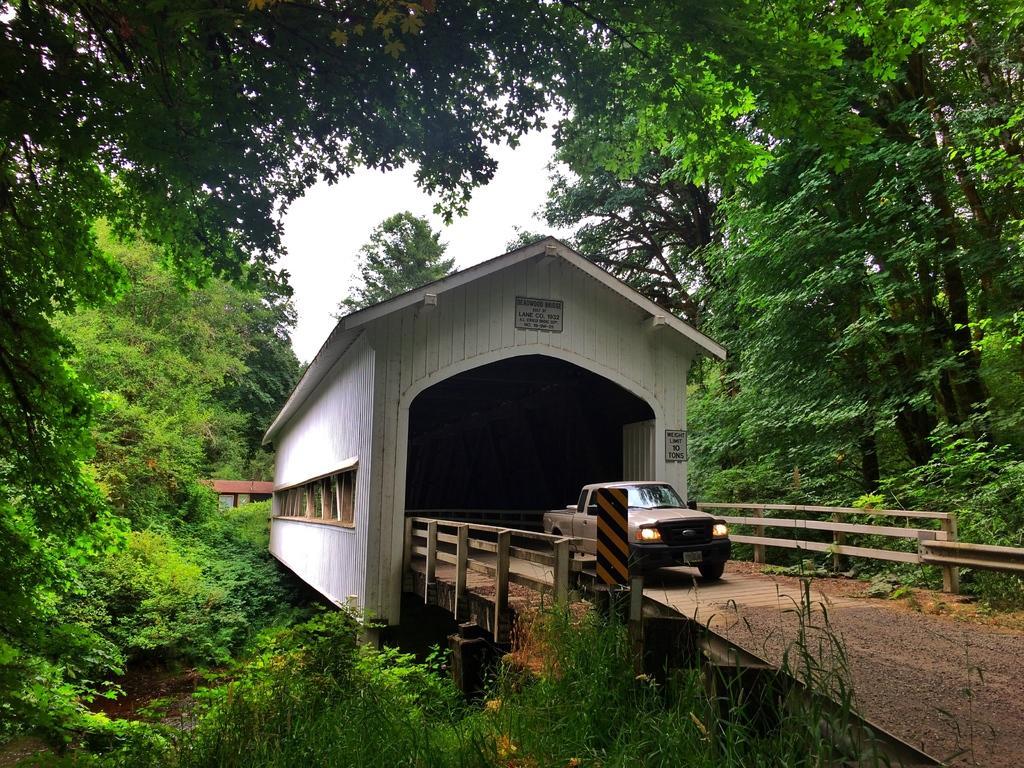Describe this image in one or two sentences. In this picture we can see a car on a bridge surrounded by trees and bushes. 